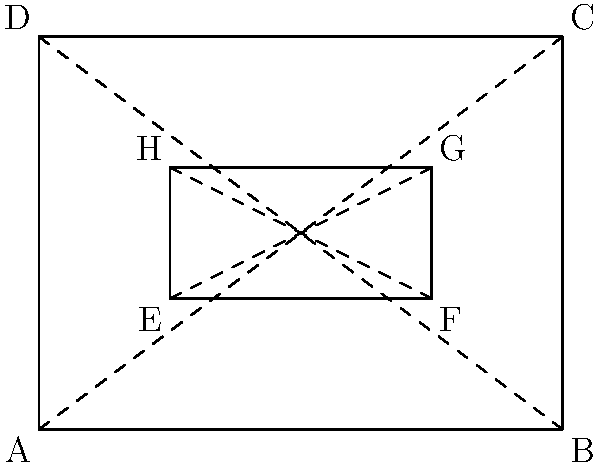You're designing a new eco-friendly packaging for a senior discount product line. The outer box ABCD is a rectangle, and the inner compartment EFGH is also rectangular. If AB = 12 cm, BC = 9 cm, and EF = 6 cm, what is the length of EH to ensure that triangles ADE and EHF are congruent? Let's approach this step-by-step:

1) First, we need to recognize that for triangles ADE and EHF to be congruent, they must have the same shape and size.

2) We know that:
   - AB = 12 cm (width of outer box)
   - BC = 9 cm (height of outer box)
   - EF = 6 cm (width of inner compartment)

3) Let's consider the width:
   - AE = HF = (AB - EF) / 2 = (12 - 6) / 2 = 3 cm

4) Now, for the triangles to be congruent, they must have the same height-to-width ratio as the outer rectangle:

   $\frac{BC}{AB} = \frac{EH}{AE}$

5) We can set up the equation:

   $\frac{9}{12} = \frac{EH}{3}$

6) Cross multiply:

   $9 * 3 = 12 * EH$
   $27 = 12 * EH$

7) Solve for EH:

   $EH = 27 / 12 = 2.25$ cm

Therefore, the length of EH should be 2.25 cm to ensure that triangles ADE and EHF are congruent.
Answer: 2.25 cm 